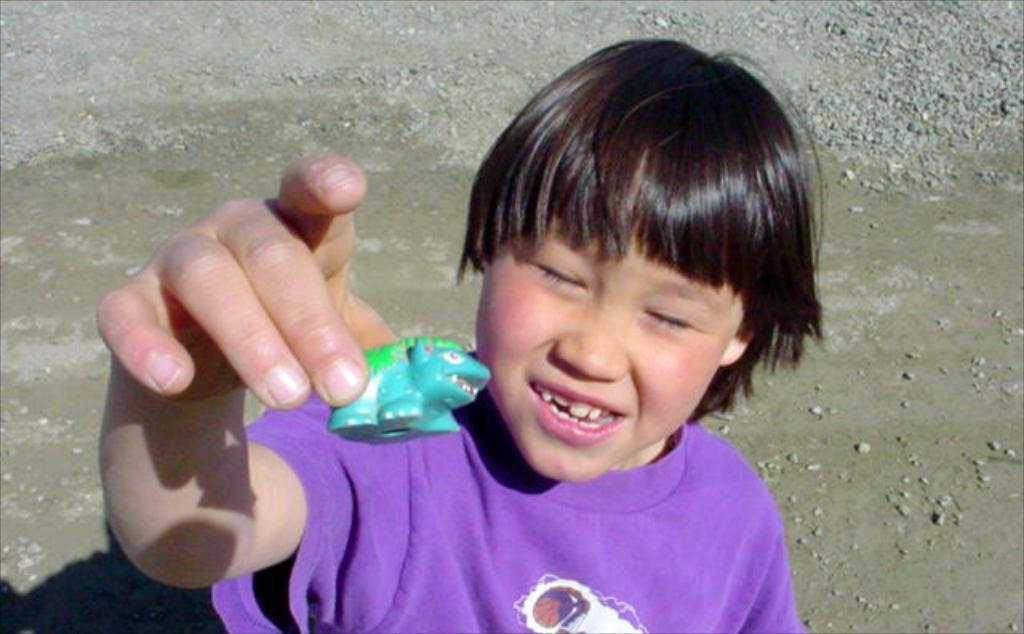What is the main subject of the image? The main subject of the image is a kid. What is the kid holding in the image? The kid is holding a toy. What can be seen in the background of the image? There are stones visible in the background of the image. What time is displayed on the faucet in the image? There is no faucet present in the image, so it is not possible to determine the time displayed on it. 